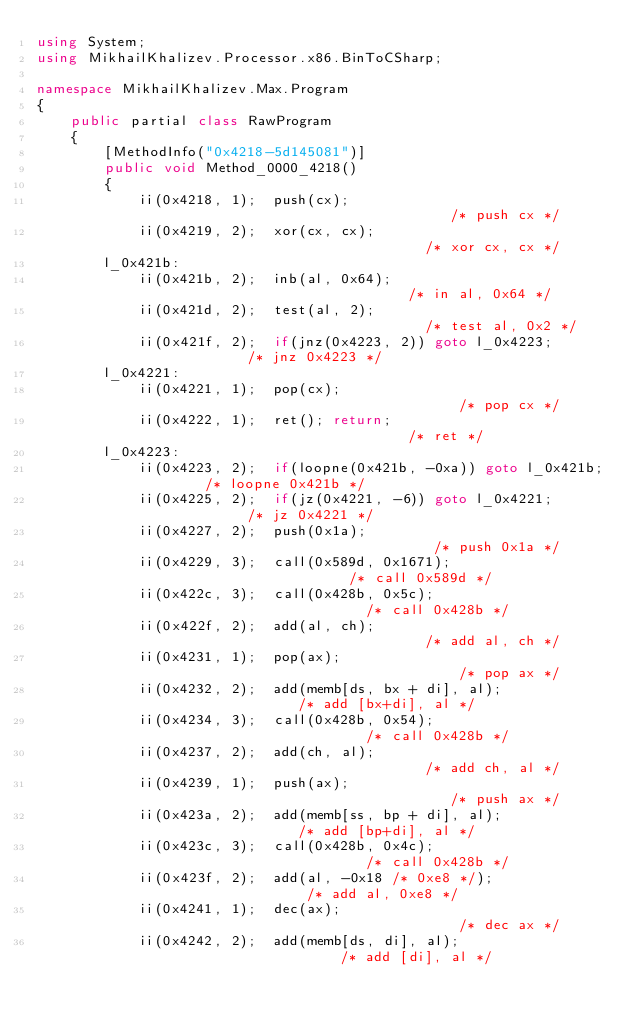<code> <loc_0><loc_0><loc_500><loc_500><_C#_>using System;
using MikhailKhalizev.Processor.x86.BinToCSharp;

namespace MikhailKhalizev.Max.Program
{
    public partial class RawProgram
    {
        [MethodInfo("0x4218-5d145081")]
        public void Method_0000_4218()
        {
            ii(0x4218, 1);  push(cx);                                  /* push cx */
            ii(0x4219, 2);  xor(cx, cx);                               /* xor cx, cx */
        l_0x421b:
            ii(0x421b, 2);  inb(al, 0x64);                             /* in al, 0x64 */
            ii(0x421d, 2);  test(al, 2);                               /* test al, 0x2 */
            ii(0x421f, 2);  if(jnz(0x4223, 2)) goto l_0x4223;          /* jnz 0x4223 */
        l_0x4221:
            ii(0x4221, 1);  pop(cx);                                   /* pop cx */
            ii(0x4222, 1);  ret(); return;                             /* ret */
        l_0x4223:
            ii(0x4223, 2);  if(loopne(0x421b, -0xa)) goto l_0x421b;    /* loopne 0x421b */
            ii(0x4225, 2);  if(jz(0x4221, -6)) goto l_0x4221;          /* jz 0x4221 */
            ii(0x4227, 2);  push(0x1a);                                /* push 0x1a */
            ii(0x4229, 3);  call(0x589d, 0x1671);                      /* call 0x589d */
            ii(0x422c, 3);  call(0x428b, 0x5c);                        /* call 0x428b */
            ii(0x422f, 2);  add(al, ch);                               /* add al, ch */
            ii(0x4231, 1);  pop(ax);                                   /* pop ax */
            ii(0x4232, 2);  add(memb[ds, bx + di], al);                /* add [bx+di], al */
            ii(0x4234, 3);  call(0x428b, 0x54);                        /* call 0x428b */
            ii(0x4237, 2);  add(ch, al);                               /* add ch, al */
            ii(0x4239, 1);  push(ax);                                  /* push ax */
            ii(0x423a, 2);  add(memb[ss, bp + di], al);                /* add [bp+di], al */
            ii(0x423c, 3);  call(0x428b, 0x4c);                        /* call 0x428b */
            ii(0x423f, 2);  add(al, -0x18 /* 0xe8 */);                 /* add al, 0xe8 */
            ii(0x4241, 1);  dec(ax);                                   /* dec ax */
            ii(0x4242, 2);  add(memb[ds, di], al);                     /* add [di], al */</code> 